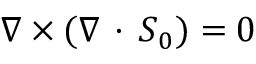Convert formula to latex. <formula><loc_0><loc_0><loc_500><loc_500>\nabla \times ( \nabla \, \cdot \, { S } _ { 0 } ) = 0</formula> 